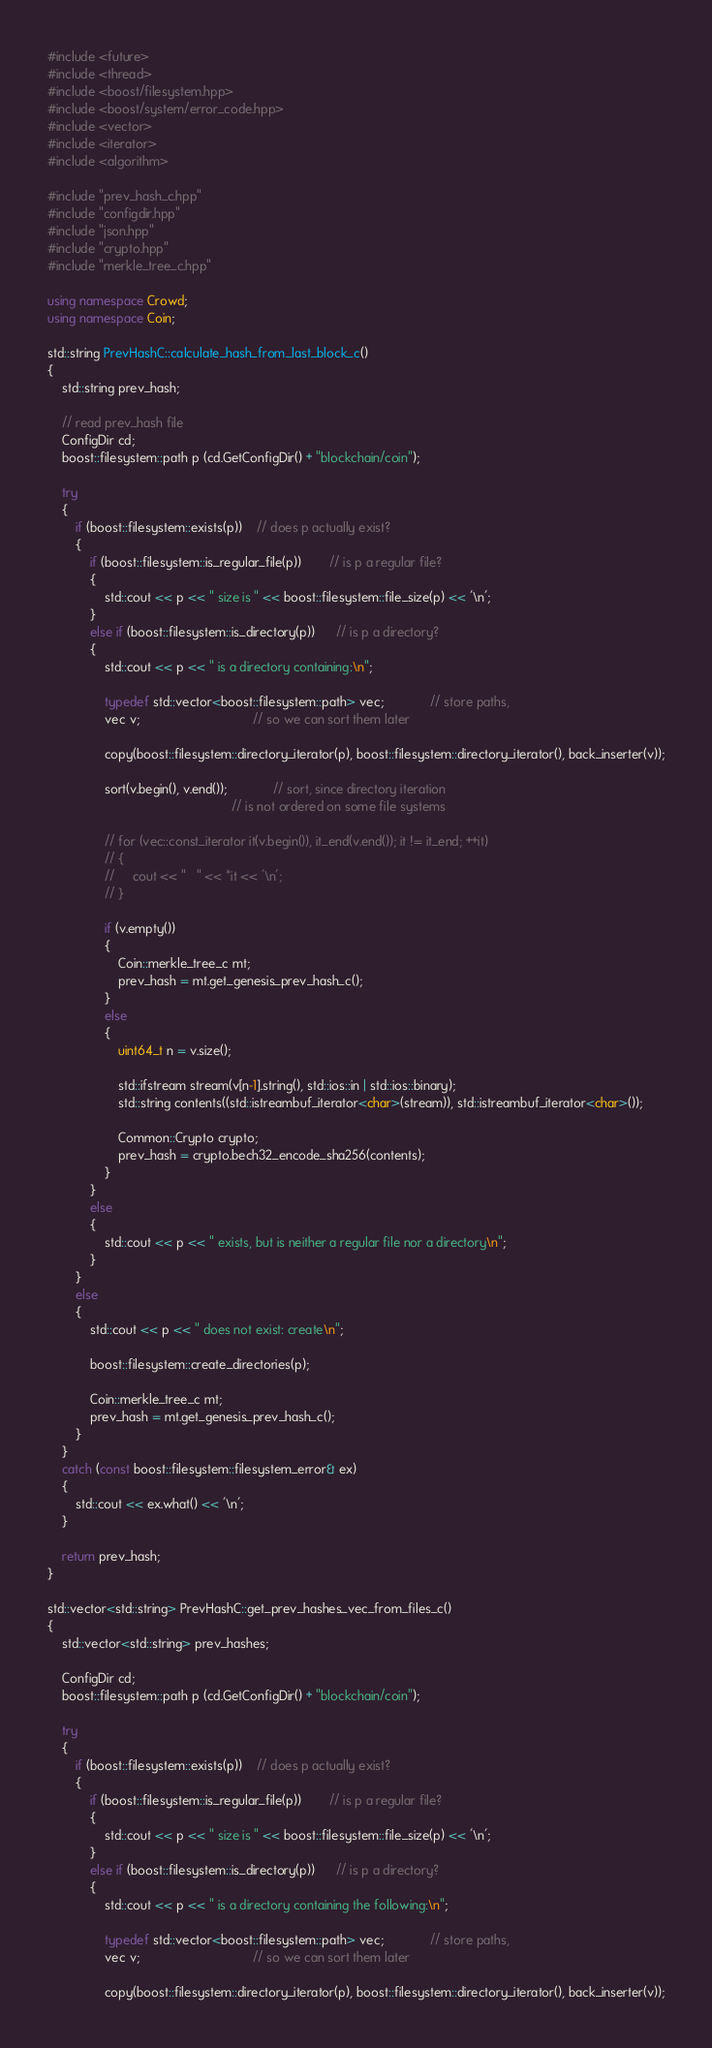Convert code to text. <code><loc_0><loc_0><loc_500><loc_500><_C++_>#include <future>
#include <thread>
#include <boost/filesystem.hpp>
#include <boost/system/error_code.hpp>
#include <vector>
#include <iterator>
#include <algorithm>

#include "prev_hash_c.hpp"
#include "configdir.hpp"
#include "json.hpp"
#include "crypto.hpp"
#include "merkle_tree_c.hpp"

using namespace Crowd;
using namespace Coin;

std::string PrevHashC::calculate_hash_from_last_block_c()
{
    std::string prev_hash;

    // read prev_hash file
    ConfigDir cd;
    boost::filesystem::path p (cd.GetConfigDir() + "blockchain/coin");

    try
    {
        if (boost::filesystem::exists(p))    // does p actually exist?
        {
            if (boost::filesystem::is_regular_file(p))        // is p a regular file?
            {
                std::cout << p << " size is " << boost::filesystem::file_size(p) << '\n';
            }
            else if (boost::filesystem::is_directory(p))      // is p a directory?
            {
                std::cout << p << " is a directory containing:\n";

                typedef std::vector<boost::filesystem::path> vec;             // store paths,
                vec v;                                // so we can sort them later

                copy(boost::filesystem::directory_iterator(p), boost::filesystem::directory_iterator(), back_inserter(v));

                sort(v.begin(), v.end());             // sort, since directory iteration
                                                    // is not ordered on some file systems

                // for (vec::const_iterator it(v.begin()), it_end(v.end()); it != it_end; ++it)
                // {
                //     cout << "   " << *it << '\n';
                // }

                if (v.empty())
                {
                    Coin::merkle_tree_c mt;
                    prev_hash = mt.get_genesis_prev_hash_c();
                }
                else
                {
                    uint64_t n = v.size(); 

                    std::ifstream stream(v[n-1].string(), std::ios::in | std::ios::binary);
                    std::string contents((std::istreambuf_iterator<char>(stream)), std::istreambuf_iterator<char>());

                    Common::Crypto crypto;
                    prev_hash = crypto.bech32_encode_sha256(contents);
                }
            }
            else
            {
                std::cout << p << " exists, but is neither a regular file nor a directory\n";
            }
        }
        else
        {
            std::cout << p << " does not exist: create\n";

            boost::filesystem::create_directories(p);

            Coin::merkle_tree_c mt;
            prev_hash = mt.get_genesis_prev_hash_c();
        }
    }
    catch (const boost::filesystem::filesystem_error& ex)
    {
        std::cout << ex.what() << '\n';
    }

    return prev_hash;
}

std::vector<std::string> PrevHashC::get_prev_hashes_vec_from_files_c()
{
    std::vector<std::string> prev_hashes;

    ConfigDir cd;
    boost::filesystem::path p (cd.GetConfigDir() + "blockchain/coin");

    try
    {
        if (boost::filesystem::exists(p))    // does p actually exist?
        {
            if (boost::filesystem::is_regular_file(p))        // is p a regular file?
            {
                std::cout << p << " size is " << boost::filesystem::file_size(p) << '\n';
            }
            else if (boost::filesystem::is_directory(p))      // is p a directory?
            {
                std::cout << p << " is a directory containing the following:\n";

                typedef std::vector<boost::filesystem::path> vec;             // store paths,
                vec v;                                // so we can sort them later

                copy(boost::filesystem::directory_iterator(p), boost::filesystem::directory_iterator(), back_inserter(v));
</code> 